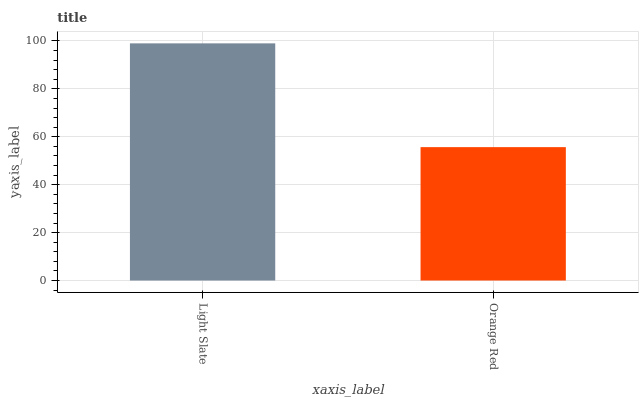Is Orange Red the minimum?
Answer yes or no. Yes. Is Light Slate the maximum?
Answer yes or no. Yes. Is Orange Red the maximum?
Answer yes or no. No. Is Light Slate greater than Orange Red?
Answer yes or no. Yes. Is Orange Red less than Light Slate?
Answer yes or no. Yes. Is Orange Red greater than Light Slate?
Answer yes or no. No. Is Light Slate less than Orange Red?
Answer yes or no. No. Is Light Slate the high median?
Answer yes or no. Yes. Is Orange Red the low median?
Answer yes or no. Yes. Is Orange Red the high median?
Answer yes or no. No. Is Light Slate the low median?
Answer yes or no. No. 